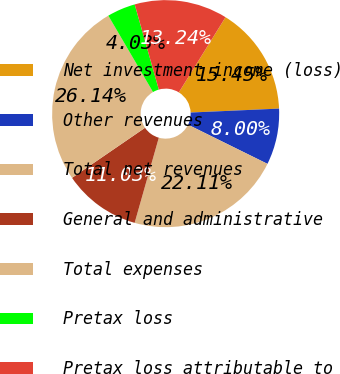Convert chart to OTSL. <chart><loc_0><loc_0><loc_500><loc_500><pie_chart><fcel>Net investment income (loss)<fcel>Other revenues<fcel>Total net revenues<fcel>General and administrative<fcel>Total expenses<fcel>Pretax loss<fcel>Pretax loss attributable to<nl><fcel>15.45%<fcel>8.0%<fcel>22.11%<fcel>11.03%<fcel>26.14%<fcel>4.03%<fcel>13.24%<nl></chart> 